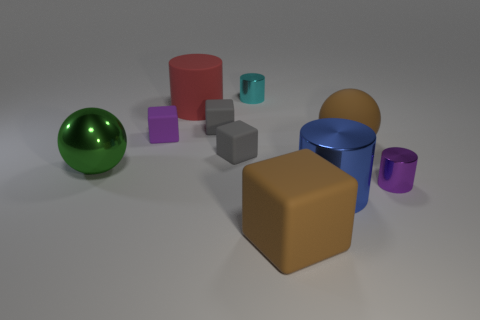What number of brown things have the same material as the big green sphere?
Your response must be concise. 0. What is the shape of the object that is the same color as the big rubber ball?
Your answer should be very brief. Cube. There is a purple rubber object that is the same size as the cyan object; what shape is it?
Your answer should be very brief. Cube. There is a big thing that is the same color as the large cube; what is its material?
Make the answer very short. Rubber. Are there any big metal spheres right of the cyan metallic cylinder?
Provide a succinct answer. No. Are there any other big rubber objects of the same shape as the large green object?
Keep it short and to the point. Yes. Does the tiny gray matte thing behind the large brown rubber sphere have the same shape as the rubber object on the left side of the red object?
Offer a very short reply. Yes. Are there any rubber things of the same size as the cyan metallic object?
Your answer should be compact. Yes. Are there an equal number of objects behind the purple metal object and cyan shiny things to the right of the big brown matte cube?
Provide a short and direct response. No. Is the large thing that is to the right of the blue thing made of the same material as the small purple object that is to the left of the small cyan shiny object?
Provide a succinct answer. Yes. 